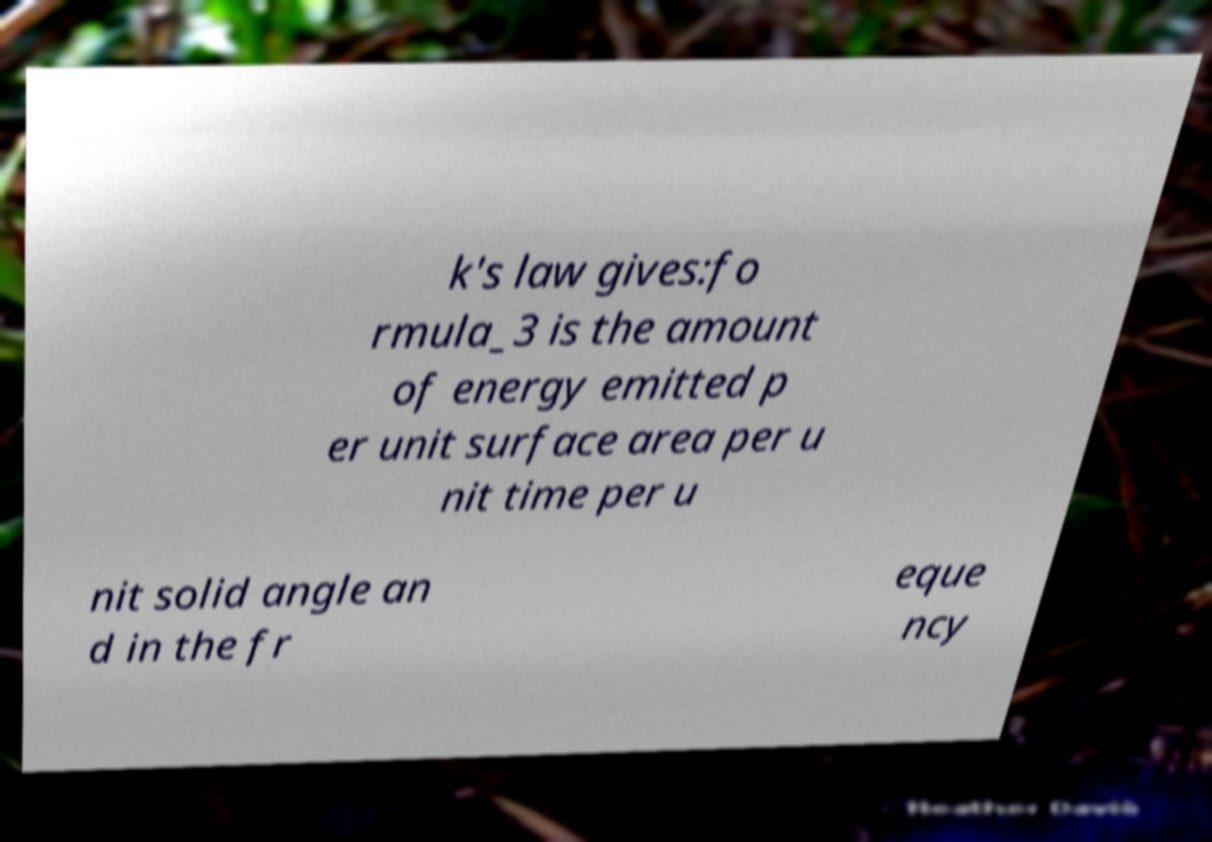What messages or text are displayed in this image? I need them in a readable, typed format. k's law gives:fo rmula_3 is the amount of energy emitted p er unit surface area per u nit time per u nit solid angle an d in the fr eque ncy 